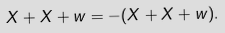<formula> <loc_0><loc_0><loc_500><loc_500>X + X + w = - ( X + X + w ) .</formula> 